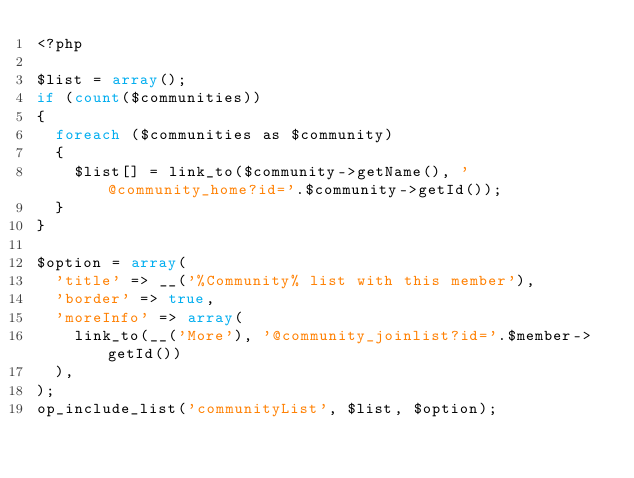Convert code to text. <code><loc_0><loc_0><loc_500><loc_500><_PHP_><?php

$list = array();
if (count($communities))
{
  foreach ($communities as $community)
  {
    $list[] = link_to($community->getName(), '@community_home?id='.$community->getId());
  }
}

$option = array(
  'title' => __('%Community% list with this member'),
  'border' => true,
  'moreInfo' => array(
    link_to(__('More'), '@community_joinlist?id='.$member->getId())
  ),
);
op_include_list('communityList', $list, $option);
</code> 